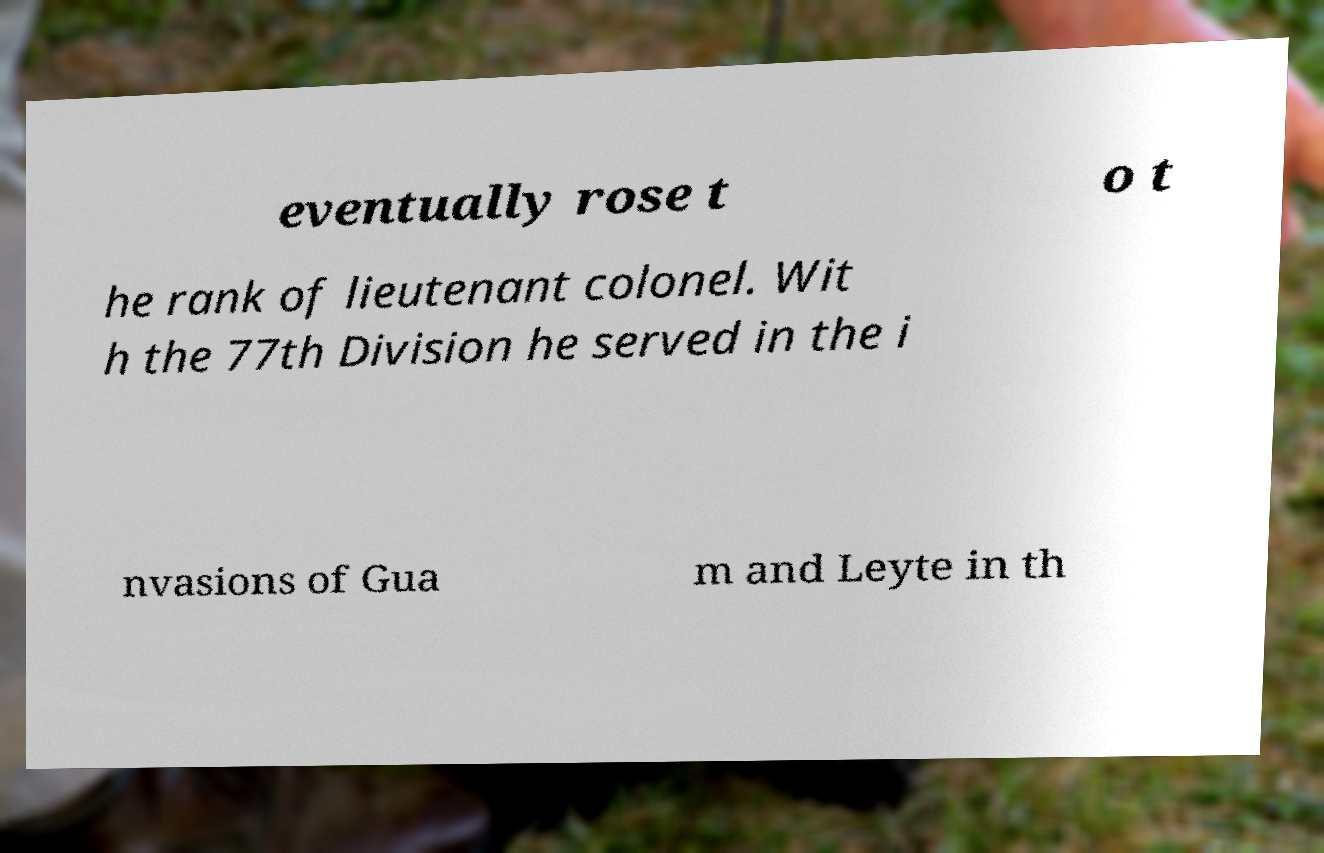Please identify and transcribe the text found in this image. eventually rose t o t he rank of lieutenant colonel. Wit h the 77th Division he served in the i nvasions of Gua m and Leyte in th 